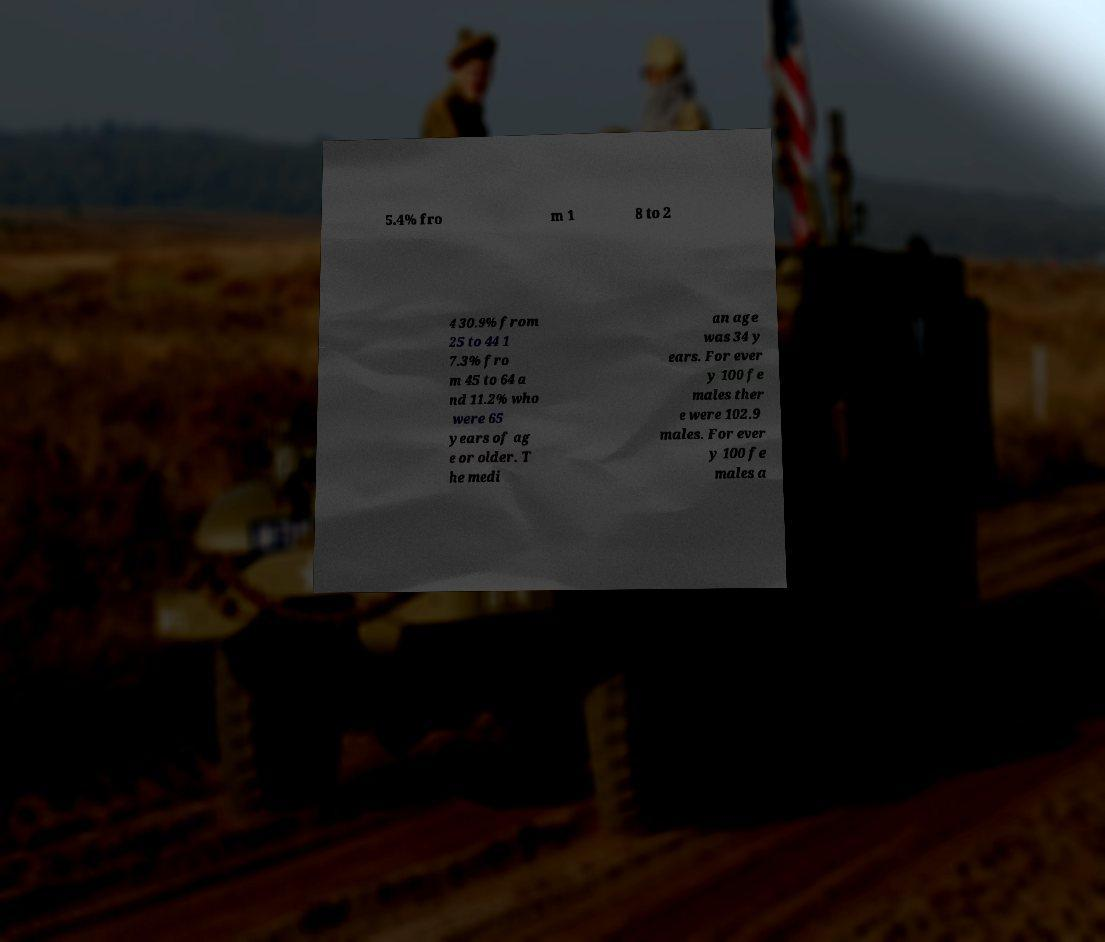Please identify and transcribe the text found in this image. 5.4% fro m 1 8 to 2 4 30.9% from 25 to 44 1 7.3% fro m 45 to 64 a nd 11.2% who were 65 years of ag e or older. T he medi an age was 34 y ears. For ever y 100 fe males ther e were 102.9 males. For ever y 100 fe males a 